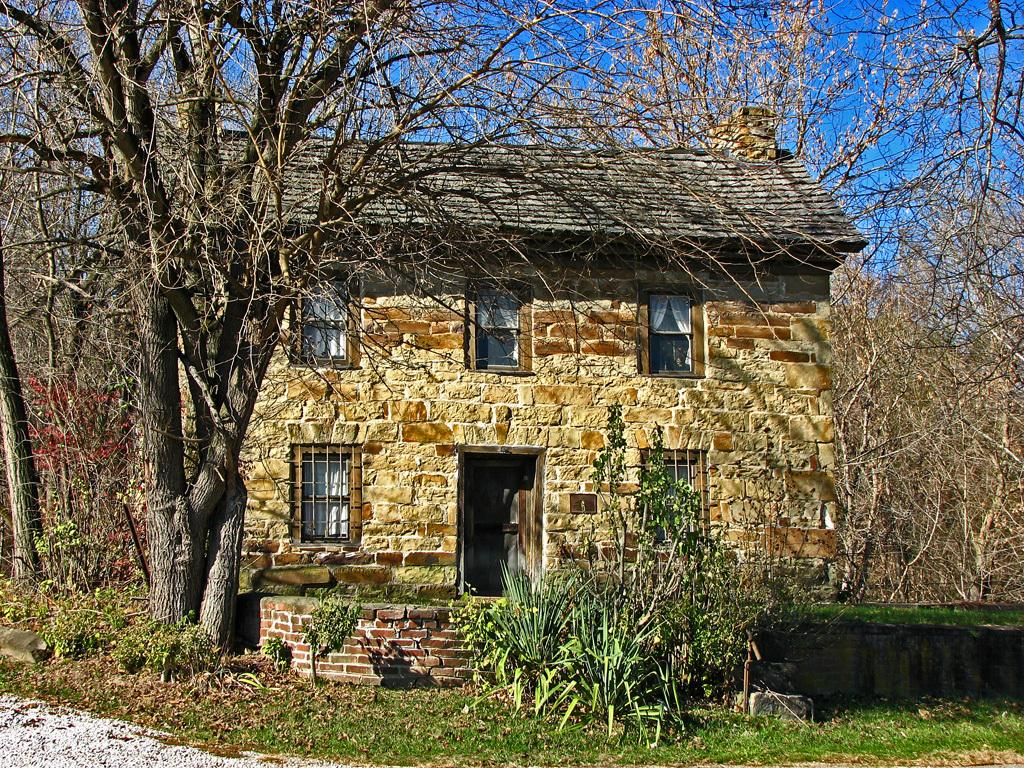What type of structure is present in the picture? There is a house in the picture. What type of vegetation can be seen in the picture? There is grass, plants, and trees in the picture. What is visible in the background of the picture? The sky is visible in the background of the picture. What type of guitar can be seen hanging on the wall in the picture? There is no guitar present in the picture; it only features a house, grass, plants, trees, and the sky. 